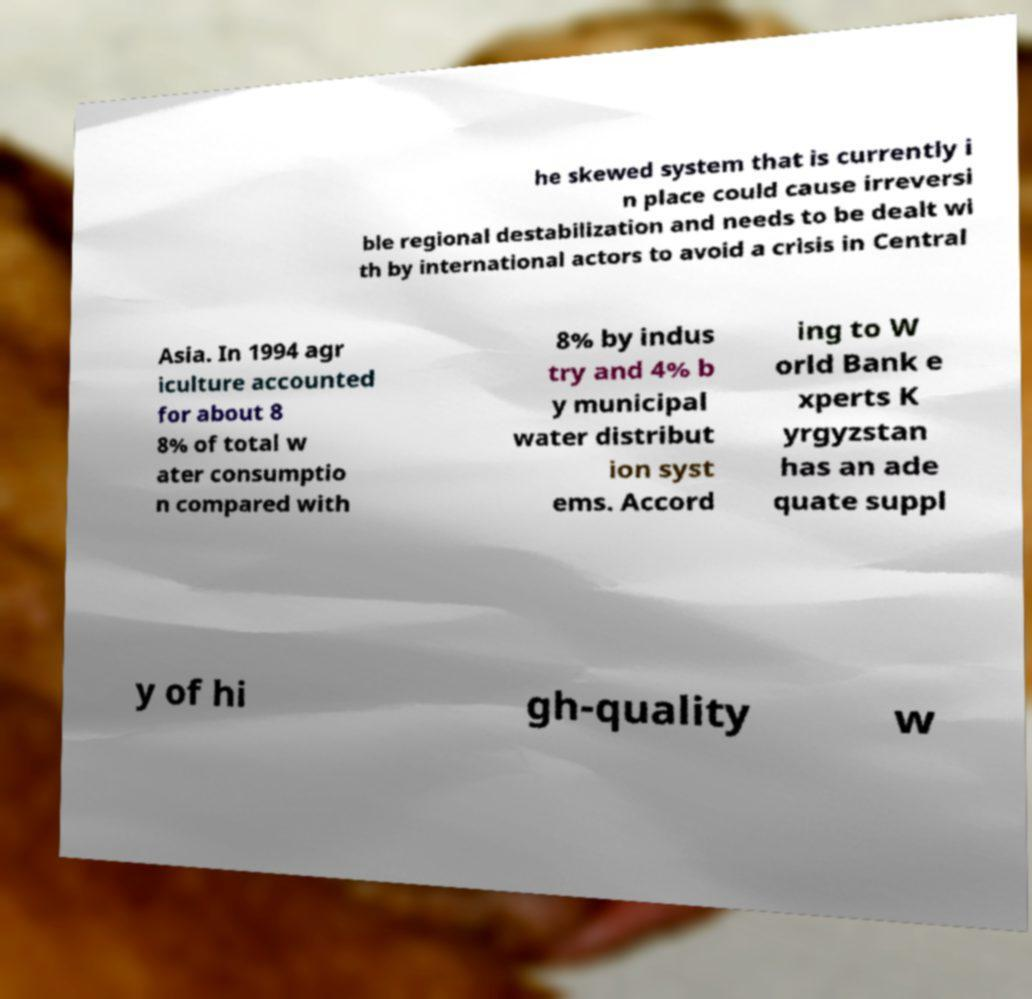Please read and relay the text visible in this image. What does it say? he skewed system that is currently i n place could cause irreversi ble regional destabilization and needs to be dealt wi th by international actors to avoid a crisis in Central Asia. In 1994 agr iculture accounted for about 8 8% of total w ater consumptio n compared with 8% by indus try and 4% b y municipal water distribut ion syst ems. Accord ing to W orld Bank e xperts K yrgyzstan has an ade quate suppl y of hi gh-quality w 